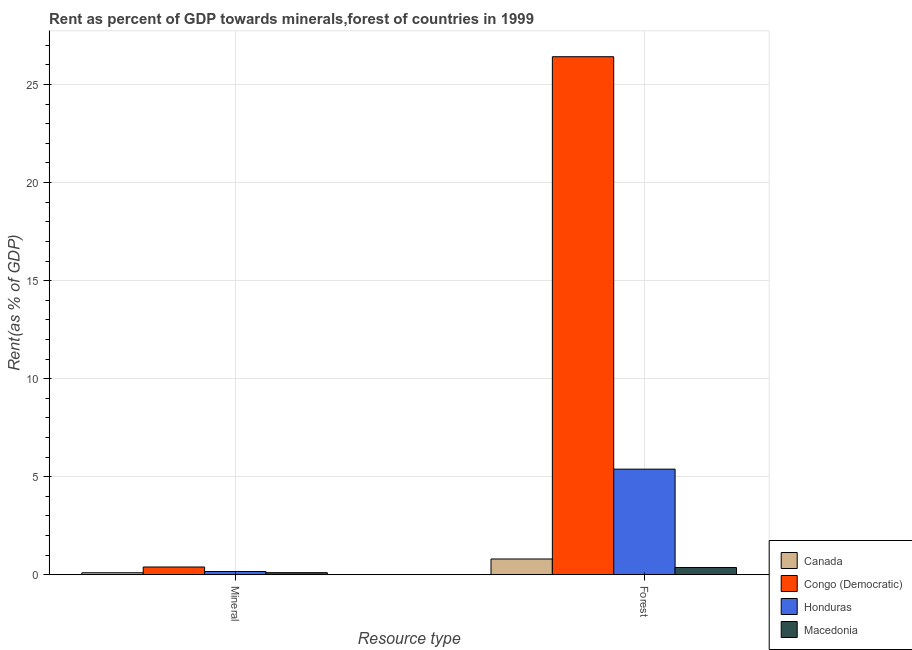How many different coloured bars are there?
Ensure brevity in your answer.  4. Are the number of bars per tick equal to the number of legend labels?
Provide a succinct answer. Yes. Are the number of bars on each tick of the X-axis equal?
Give a very brief answer. Yes. How many bars are there on the 1st tick from the right?
Your answer should be very brief. 4. What is the label of the 2nd group of bars from the left?
Your answer should be compact. Forest. What is the mineral rent in Macedonia?
Your answer should be very brief. 0.1. Across all countries, what is the maximum mineral rent?
Give a very brief answer. 0.39. Across all countries, what is the minimum mineral rent?
Make the answer very short. 0.1. In which country was the forest rent maximum?
Keep it short and to the point. Congo (Democratic). In which country was the mineral rent minimum?
Your answer should be very brief. Canada. What is the total forest rent in the graph?
Your answer should be compact. 32.97. What is the difference between the mineral rent in Macedonia and that in Canada?
Provide a short and direct response. 0.01. What is the difference between the forest rent in Honduras and the mineral rent in Congo (Democratic)?
Offer a terse response. 4.99. What is the average forest rent per country?
Offer a terse response. 8.24. What is the difference between the mineral rent and forest rent in Honduras?
Ensure brevity in your answer.  -5.22. In how many countries, is the forest rent greater than 10 %?
Keep it short and to the point. 1. What is the ratio of the forest rent in Congo (Democratic) to that in Macedonia?
Provide a succinct answer. 72.27. What does the 2nd bar from the right in Forest represents?
Offer a very short reply. Honduras. How many bars are there?
Ensure brevity in your answer.  8. Are all the bars in the graph horizontal?
Make the answer very short. No. How many countries are there in the graph?
Your response must be concise. 4. Are the values on the major ticks of Y-axis written in scientific E-notation?
Provide a succinct answer. No. How many legend labels are there?
Make the answer very short. 4. How are the legend labels stacked?
Provide a succinct answer. Vertical. What is the title of the graph?
Provide a short and direct response. Rent as percent of GDP towards minerals,forest of countries in 1999. Does "Poland" appear as one of the legend labels in the graph?
Your response must be concise. No. What is the label or title of the X-axis?
Your response must be concise. Resource type. What is the label or title of the Y-axis?
Ensure brevity in your answer.  Rent(as % of GDP). What is the Rent(as % of GDP) in Canada in Mineral?
Ensure brevity in your answer.  0.1. What is the Rent(as % of GDP) in Congo (Democratic) in Mineral?
Make the answer very short. 0.39. What is the Rent(as % of GDP) of Honduras in Mineral?
Provide a short and direct response. 0.16. What is the Rent(as % of GDP) of Macedonia in Mineral?
Your answer should be compact. 0.1. What is the Rent(as % of GDP) in Canada in Forest?
Provide a short and direct response. 0.8. What is the Rent(as % of GDP) of Congo (Democratic) in Forest?
Your response must be concise. 26.42. What is the Rent(as % of GDP) of Honduras in Forest?
Offer a very short reply. 5.38. What is the Rent(as % of GDP) in Macedonia in Forest?
Give a very brief answer. 0.37. Across all Resource type, what is the maximum Rent(as % of GDP) in Canada?
Keep it short and to the point. 0.8. Across all Resource type, what is the maximum Rent(as % of GDP) in Congo (Democratic)?
Ensure brevity in your answer.  26.42. Across all Resource type, what is the maximum Rent(as % of GDP) of Honduras?
Make the answer very short. 5.38. Across all Resource type, what is the maximum Rent(as % of GDP) of Macedonia?
Provide a short and direct response. 0.37. Across all Resource type, what is the minimum Rent(as % of GDP) in Canada?
Provide a succinct answer. 0.1. Across all Resource type, what is the minimum Rent(as % of GDP) of Congo (Democratic)?
Offer a terse response. 0.39. Across all Resource type, what is the minimum Rent(as % of GDP) in Honduras?
Your answer should be very brief. 0.16. Across all Resource type, what is the minimum Rent(as % of GDP) of Macedonia?
Your response must be concise. 0.1. What is the total Rent(as % of GDP) in Canada in the graph?
Offer a very short reply. 0.9. What is the total Rent(as % of GDP) of Congo (Democratic) in the graph?
Make the answer very short. 26.81. What is the total Rent(as % of GDP) in Honduras in the graph?
Offer a very short reply. 5.55. What is the total Rent(as % of GDP) of Macedonia in the graph?
Your answer should be very brief. 0.47. What is the difference between the Rent(as % of GDP) in Canada in Mineral and that in Forest?
Your response must be concise. -0.7. What is the difference between the Rent(as % of GDP) of Congo (Democratic) in Mineral and that in Forest?
Your answer should be very brief. -26.03. What is the difference between the Rent(as % of GDP) of Honduras in Mineral and that in Forest?
Your answer should be very brief. -5.22. What is the difference between the Rent(as % of GDP) of Macedonia in Mineral and that in Forest?
Give a very brief answer. -0.26. What is the difference between the Rent(as % of GDP) of Canada in Mineral and the Rent(as % of GDP) of Congo (Democratic) in Forest?
Your answer should be very brief. -26.32. What is the difference between the Rent(as % of GDP) of Canada in Mineral and the Rent(as % of GDP) of Honduras in Forest?
Ensure brevity in your answer.  -5.29. What is the difference between the Rent(as % of GDP) in Canada in Mineral and the Rent(as % of GDP) in Macedonia in Forest?
Your answer should be very brief. -0.27. What is the difference between the Rent(as % of GDP) of Congo (Democratic) in Mineral and the Rent(as % of GDP) of Honduras in Forest?
Your answer should be compact. -4.99. What is the difference between the Rent(as % of GDP) in Congo (Democratic) in Mineral and the Rent(as % of GDP) in Macedonia in Forest?
Provide a succinct answer. 0.03. What is the difference between the Rent(as % of GDP) of Honduras in Mineral and the Rent(as % of GDP) of Macedonia in Forest?
Offer a terse response. -0.2. What is the average Rent(as % of GDP) in Canada per Resource type?
Offer a terse response. 0.45. What is the average Rent(as % of GDP) of Congo (Democratic) per Resource type?
Offer a terse response. 13.41. What is the average Rent(as % of GDP) of Honduras per Resource type?
Your answer should be compact. 2.77. What is the average Rent(as % of GDP) in Macedonia per Resource type?
Provide a short and direct response. 0.23. What is the difference between the Rent(as % of GDP) of Canada and Rent(as % of GDP) of Congo (Democratic) in Mineral?
Your response must be concise. -0.29. What is the difference between the Rent(as % of GDP) in Canada and Rent(as % of GDP) in Honduras in Mineral?
Offer a very short reply. -0.06. What is the difference between the Rent(as % of GDP) of Canada and Rent(as % of GDP) of Macedonia in Mineral?
Ensure brevity in your answer.  -0.01. What is the difference between the Rent(as % of GDP) in Congo (Democratic) and Rent(as % of GDP) in Honduras in Mineral?
Make the answer very short. 0.23. What is the difference between the Rent(as % of GDP) in Congo (Democratic) and Rent(as % of GDP) in Macedonia in Mineral?
Your response must be concise. 0.29. What is the difference between the Rent(as % of GDP) of Honduras and Rent(as % of GDP) of Macedonia in Mineral?
Provide a short and direct response. 0.06. What is the difference between the Rent(as % of GDP) in Canada and Rent(as % of GDP) in Congo (Democratic) in Forest?
Your response must be concise. -25.62. What is the difference between the Rent(as % of GDP) in Canada and Rent(as % of GDP) in Honduras in Forest?
Offer a very short reply. -4.58. What is the difference between the Rent(as % of GDP) of Canada and Rent(as % of GDP) of Macedonia in Forest?
Make the answer very short. 0.44. What is the difference between the Rent(as % of GDP) of Congo (Democratic) and Rent(as % of GDP) of Honduras in Forest?
Provide a succinct answer. 21.04. What is the difference between the Rent(as % of GDP) in Congo (Democratic) and Rent(as % of GDP) in Macedonia in Forest?
Your answer should be compact. 26.06. What is the difference between the Rent(as % of GDP) in Honduras and Rent(as % of GDP) in Macedonia in Forest?
Your response must be concise. 5.02. What is the ratio of the Rent(as % of GDP) in Canada in Mineral to that in Forest?
Make the answer very short. 0.12. What is the ratio of the Rent(as % of GDP) in Congo (Democratic) in Mineral to that in Forest?
Make the answer very short. 0.01. What is the ratio of the Rent(as % of GDP) in Honduras in Mineral to that in Forest?
Your response must be concise. 0.03. What is the ratio of the Rent(as % of GDP) in Macedonia in Mineral to that in Forest?
Your answer should be compact. 0.28. What is the difference between the highest and the second highest Rent(as % of GDP) of Canada?
Keep it short and to the point. 0.7. What is the difference between the highest and the second highest Rent(as % of GDP) of Congo (Democratic)?
Make the answer very short. 26.03. What is the difference between the highest and the second highest Rent(as % of GDP) of Honduras?
Keep it short and to the point. 5.22. What is the difference between the highest and the second highest Rent(as % of GDP) of Macedonia?
Your answer should be compact. 0.26. What is the difference between the highest and the lowest Rent(as % of GDP) of Canada?
Give a very brief answer. 0.7. What is the difference between the highest and the lowest Rent(as % of GDP) in Congo (Democratic)?
Provide a succinct answer. 26.03. What is the difference between the highest and the lowest Rent(as % of GDP) of Honduras?
Your answer should be very brief. 5.22. What is the difference between the highest and the lowest Rent(as % of GDP) of Macedonia?
Keep it short and to the point. 0.26. 